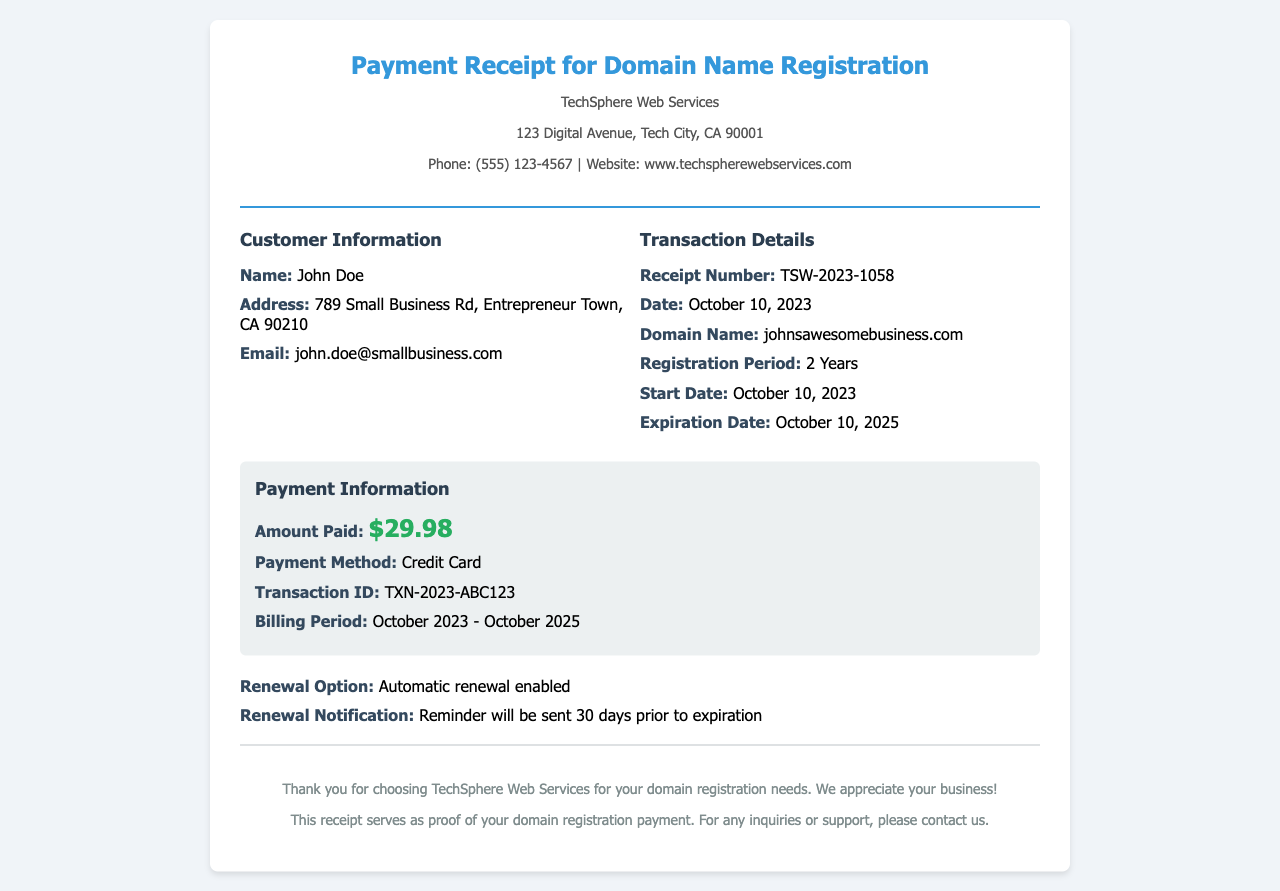What is the receipt number? The receipt number is provided in the transaction details section of the document.
Answer: TSW-2023-1058 Who is the customer? The customer’s name is listed in the customer information section of the document.
Answer: John Doe What is the amount paid? The amount paid is specified in the payment information section.
Answer: $29.98 What is the expiration date of the domain? The expiration date is found in the transaction details.
Answer: October 10, 2025 What is the payment method? The payment method can be located in the payment information section of the document.
Answer: Credit Card How long is the registration period? The registration period is mentioned in the transaction details.
Answer: 2 Years When will the renewal notification be sent? The renewal notification details are noted in the document, indicating when the reminder will be sent.
Answer: 30 days prior to expiration What is the start date of the registration? The start date of the registration is indicated in the transaction details.
Answer: October 10, 2023 Is automatic renewal enabled? The renewal option is mentioned in the payment information section.
Answer: Yes 